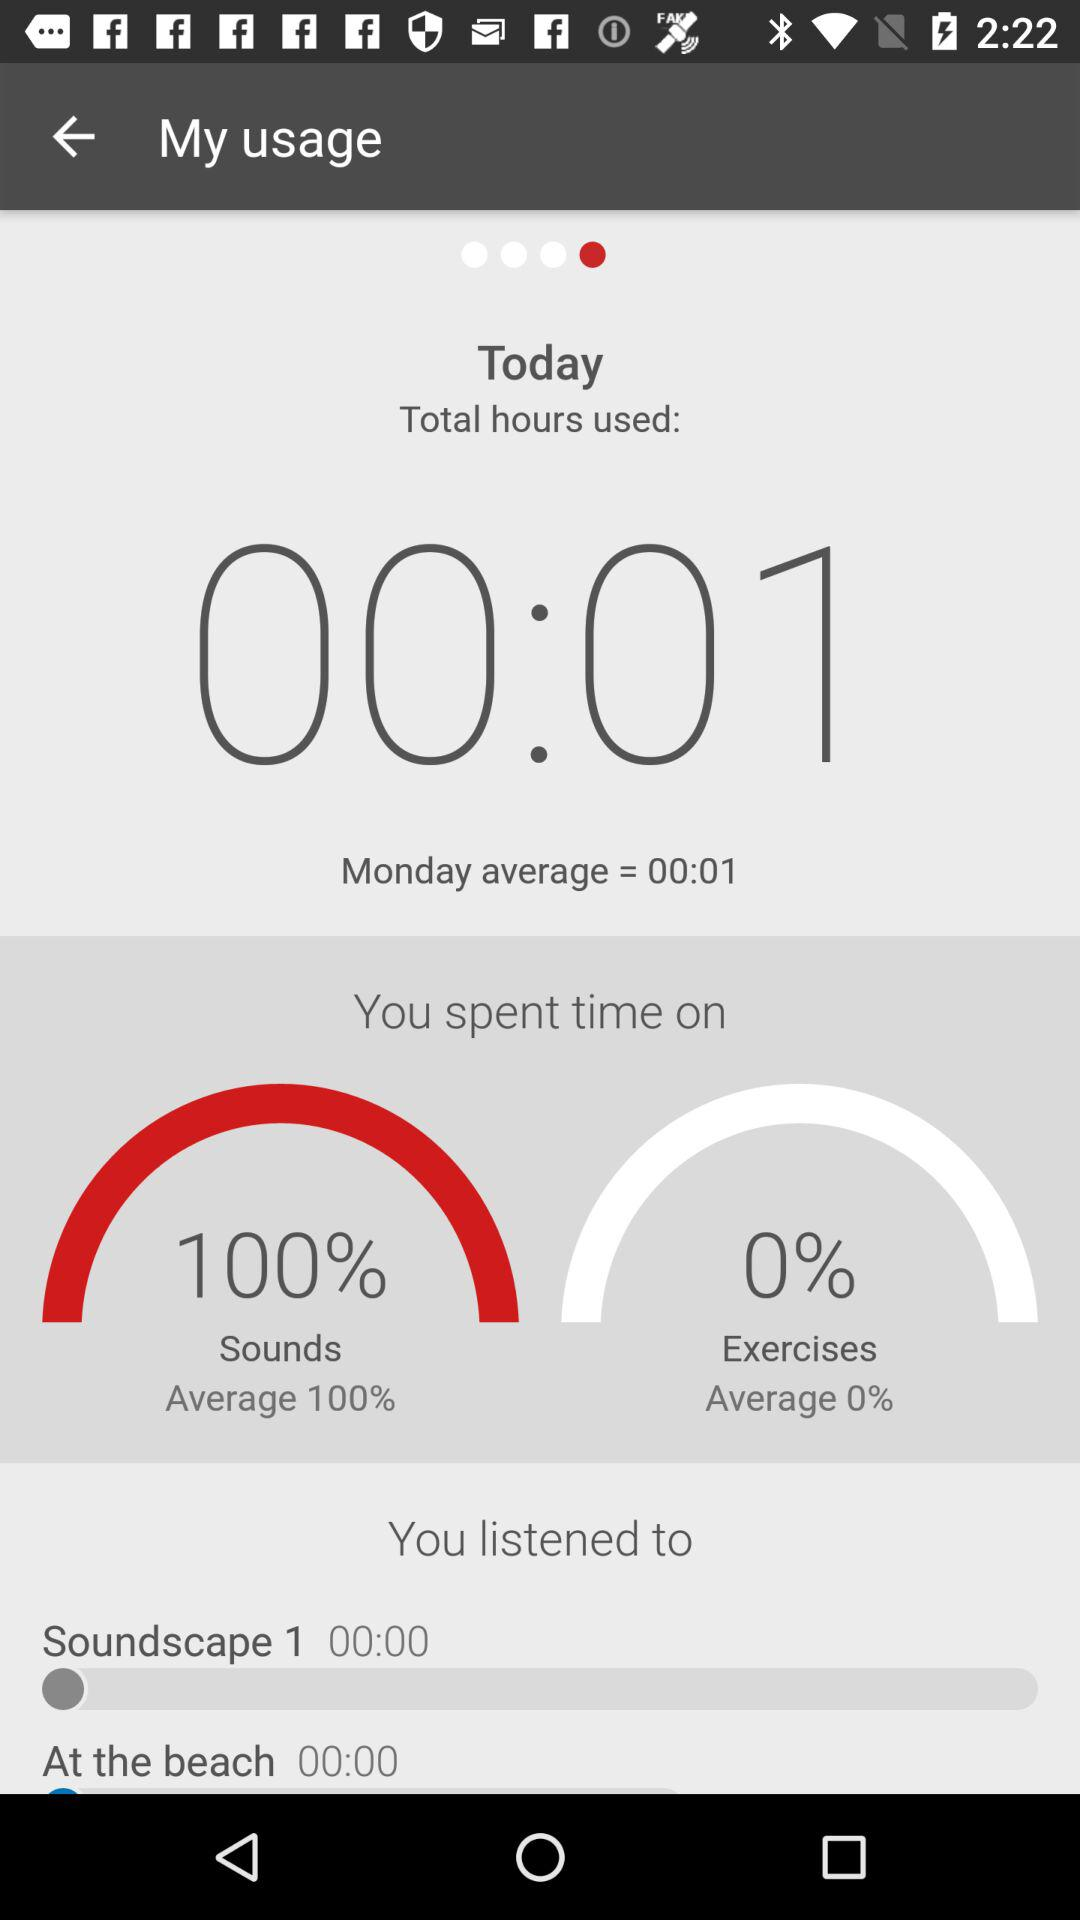What's the total number of hours used on Monday? The total number of hours used on Monday is 00:01. 